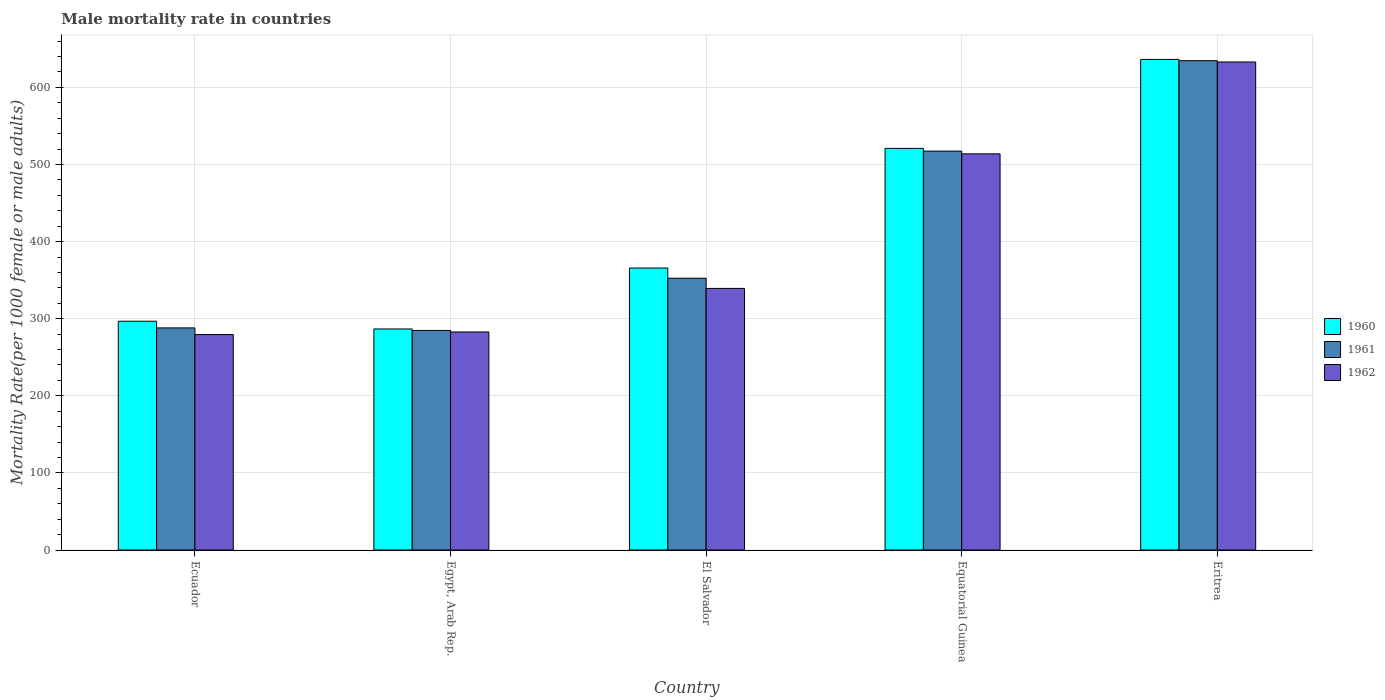How many different coloured bars are there?
Give a very brief answer. 3. How many groups of bars are there?
Keep it short and to the point. 5. Are the number of bars per tick equal to the number of legend labels?
Ensure brevity in your answer.  Yes. Are the number of bars on each tick of the X-axis equal?
Give a very brief answer. Yes. How many bars are there on the 1st tick from the right?
Provide a short and direct response. 3. What is the label of the 1st group of bars from the left?
Your answer should be very brief. Ecuador. What is the male mortality rate in 1961 in Egypt, Arab Rep.?
Make the answer very short. 284.74. Across all countries, what is the maximum male mortality rate in 1961?
Offer a very short reply. 634.63. Across all countries, what is the minimum male mortality rate in 1960?
Ensure brevity in your answer.  286.69. In which country was the male mortality rate in 1960 maximum?
Provide a short and direct response. Eritrea. In which country was the male mortality rate in 1962 minimum?
Ensure brevity in your answer.  Ecuador. What is the total male mortality rate in 1960 in the graph?
Keep it short and to the point. 2106.34. What is the difference between the male mortality rate in 1960 in Ecuador and that in Egypt, Arab Rep.?
Provide a short and direct response. 10.02. What is the difference between the male mortality rate in 1962 in Eritrea and the male mortality rate in 1961 in Ecuador?
Your answer should be very brief. 344.9. What is the average male mortality rate in 1961 per country?
Offer a very short reply. 415.46. What is the difference between the male mortality rate of/in 1960 and male mortality rate of/in 1961 in El Salvador?
Your response must be concise. 13.23. In how many countries, is the male mortality rate in 1960 greater than 320?
Make the answer very short. 3. What is the ratio of the male mortality rate in 1962 in Ecuador to that in Eritrea?
Your answer should be compact. 0.44. Is the male mortality rate in 1962 in Ecuador less than that in Eritrea?
Keep it short and to the point. Yes. What is the difference between the highest and the second highest male mortality rate in 1961?
Provide a short and direct response. -282.13. What is the difference between the highest and the lowest male mortality rate in 1962?
Offer a very short reply. 353.55. In how many countries, is the male mortality rate in 1962 greater than the average male mortality rate in 1962 taken over all countries?
Offer a very short reply. 2. What does the 3rd bar from the left in Egypt, Arab Rep. represents?
Offer a very short reply. 1962. Are the values on the major ticks of Y-axis written in scientific E-notation?
Offer a very short reply. No. Where does the legend appear in the graph?
Provide a succinct answer. Center right. What is the title of the graph?
Offer a terse response. Male mortality rate in countries. Does "2005" appear as one of the legend labels in the graph?
Your response must be concise. No. What is the label or title of the X-axis?
Provide a succinct answer. Country. What is the label or title of the Y-axis?
Ensure brevity in your answer.  Mortality Rate(per 1000 female or male adults). What is the Mortality Rate(per 1000 female or male adults) in 1960 in Ecuador?
Provide a succinct answer. 296.71. What is the Mortality Rate(per 1000 female or male adults) in 1961 in Ecuador?
Make the answer very short. 288.06. What is the Mortality Rate(per 1000 female or male adults) of 1962 in Ecuador?
Your answer should be very brief. 279.4. What is the Mortality Rate(per 1000 female or male adults) in 1960 in Egypt, Arab Rep.?
Give a very brief answer. 286.69. What is the Mortality Rate(per 1000 female or male adults) of 1961 in Egypt, Arab Rep.?
Keep it short and to the point. 284.74. What is the Mortality Rate(per 1000 female or male adults) of 1962 in Egypt, Arab Rep.?
Offer a very short reply. 282.8. What is the Mortality Rate(per 1000 female or male adults) in 1960 in El Salvador?
Your response must be concise. 365.73. What is the Mortality Rate(per 1000 female or male adults) in 1961 in El Salvador?
Your answer should be very brief. 352.5. What is the Mortality Rate(per 1000 female or male adults) in 1962 in El Salvador?
Your answer should be very brief. 339.27. What is the Mortality Rate(per 1000 female or male adults) of 1960 in Equatorial Guinea?
Offer a very short reply. 520.91. What is the Mortality Rate(per 1000 female or male adults) in 1961 in Equatorial Guinea?
Give a very brief answer. 517.37. What is the Mortality Rate(per 1000 female or male adults) of 1962 in Equatorial Guinea?
Your answer should be compact. 513.83. What is the Mortality Rate(per 1000 female or male adults) of 1960 in Eritrea?
Make the answer very short. 636.3. What is the Mortality Rate(per 1000 female or male adults) in 1961 in Eritrea?
Make the answer very short. 634.63. What is the Mortality Rate(per 1000 female or male adults) of 1962 in Eritrea?
Offer a very short reply. 632.96. Across all countries, what is the maximum Mortality Rate(per 1000 female or male adults) in 1960?
Your response must be concise. 636.3. Across all countries, what is the maximum Mortality Rate(per 1000 female or male adults) of 1961?
Your answer should be compact. 634.63. Across all countries, what is the maximum Mortality Rate(per 1000 female or male adults) in 1962?
Offer a terse response. 632.96. Across all countries, what is the minimum Mortality Rate(per 1000 female or male adults) in 1960?
Make the answer very short. 286.69. Across all countries, what is the minimum Mortality Rate(per 1000 female or male adults) in 1961?
Ensure brevity in your answer.  284.74. Across all countries, what is the minimum Mortality Rate(per 1000 female or male adults) in 1962?
Offer a terse response. 279.4. What is the total Mortality Rate(per 1000 female or male adults) in 1960 in the graph?
Provide a succinct answer. 2106.34. What is the total Mortality Rate(per 1000 female or male adults) in 1961 in the graph?
Make the answer very short. 2077.3. What is the total Mortality Rate(per 1000 female or male adults) in 1962 in the graph?
Ensure brevity in your answer.  2048.25. What is the difference between the Mortality Rate(per 1000 female or male adults) in 1960 in Ecuador and that in Egypt, Arab Rep.?
Offer a very short reply. 10.02. What is the difference between the Mortality Rate(per 1000 female or male adults) of 1961 in Ecuador and that in Egypt, Arab Rep.?
Ensure brevity in your answer.  3.32. What is the difference between the Mortality Rate(per 1000 female or male adults) in 1962 in Ecuador and that in Egypt, Arab Rep.?
Give a very brief answer. -3.39. What is the difference between the Mortality Rate(per 1000 female or male adults) of 1960 in Ecuador and that in El Salvador?
Your answer should be compact. -69.01. What is the difference between the Mortality Rate(per 1000 female or male adults) of 1961 in Ecuador and that in El Salvador?
Your answer should be compact. -64.44. What is the difference between the Mortality Rate(per 1000 female or male adults) in 1962 in Ecuador and that in El Salvador?
Provide a short and direct response. -59.86. What is the difference between the Mortality Rate(per 1000 female or male adults) in 1960 in Ecuador and that in Equatorial Guinea?
Make the answer very short. -224.2. What is the difference between the Mortality Rate(per 1000 female or male adults) of 1961 in Ecuador and that in Equatorial Guinea?
Ensure brevity in your answer.  -229.31. What is the difference between the Mortality Rate(per 1000 female or male adults) of 1962 in Ecuador and that in Equatorial Guinea?
Ensure brevity in your answer.  -234.42. What is the difference between the Mortality Rate(per 1000 female or male adults) of 1960 in Ecuador and that in Eritrea?
Your response must be concise. -339.58. What is the difference between the Mortality Rate(per 1000 female or male adults) in 1961 in Ecuador and that in Eritrea?
Offer a terse response. -346.57. What is the difference between the Mortality Rate(per 1000 female or male adults) of 1962 in Ecuador and that in Eritrea?
Provide a short and direct response. -353.55. What is the difference between the Mortality Rate(per 1000 female or male adults) in 1960 in Egypt, Arab Rep. and that in El Salvador?
Provide a short and direct response. -79.03. What is the difference between the Mortality Rate(per 1000 female or male adults) of 1961 in Egypt, Arab Rep. and that in El Salvador?
Your answer should be compact. -67.75. What is the difference between the Mortality Rate(per 1000 female or male adults) of 1962 in Egypt, Arab Rep. and that in El Salvador?
Your answer should be compact. -56.47. What is the difference between the Mortality Rate(per 1000 female or male adults) in 1960 in Egypt, Arab Rep. and that in Equatorial Guinea?
Your answer should be very brief. -234.22. What is the difference between the Mortality Rate(per 1000 female or male adults) in 1961 in Egypt, Arab Rep. and that in Equatorial Guinea?
Offer a terse response. -232.62. What is the difference between the Mortality Rate(per 1000 female or male adults) in 1962 in Egypt, Arab Rep. and that in Equatorial Guinea?
Provide a succinct answer. -231.03. What is the difference between the Mortality Rate(per 1000 female or male adults) of 1960 in Egypt, Arab Rep. and that in Eritrea?
Your answer should be compact. -349.61. What is the difference between the Mortality Rate(per 1000 female or male adults) in 1961 in Egypt, Arab Rep. and that in Eritrea?
Make the answer very short. -349.88. What is the difference between the Mortality Rate(per 1000 female or male adults) of 1962 in Egypt, Arab Rep. and that in Eritrea?
Keep it short and to the point. -350.16. What is the difference between the Mortality Rate(per 1000 female or male adults) in 1960 in El Salvador and that in Equatorial Guinea?
Your answer should be compact. -155.19. What is the difference between the Mortality Rate(per 1000 female or male adults) in 1961 in El Salvador and that in Equatorial Guinea?
Make the answer very short. -164.87. What is the difference between the Mortality Rate(per 1000 female or male adults) of 1962 in El Salvador and that in Equatorial Guinea?
Offer a very short reply. -174.56. What is the difference between the Mortality Rate(per 1000 female or male adults) of 1960 in El Salvador and that in Eritrea?
Offer a terse response. -270.57. What is the difference between the Mortality Rate(per 1000 female or male adults) in 1961 in El Salvador and that in Eritrea?
Ensure brevity in your answer.  -282.13. What is the difference between the Mortality Rate(per 1000 female or male adults) of 1962 in El Salvador and that in Eritrea?
Make the answer very short. -293.69. What is the difference between the Mortality Rate(per 1000 female or male adults) in 1960 in Equatorial Guinea and that in Eritrea?
Make the answer very short. -115.39. What is the difference between the Mortality Rate(per 1000 female or male adults) of 1961 in Equatorial Guinea and that in Eritrea?
Offer a terse response. -117.26. What is the difference between the Mortality Rate(per 1000 female or male adults) of 1962 in Equatorial Guinea and that in Eritrea?
Your answer should be compact. -119.13. What is the difference between the Mortality Rate(per 1000 female or male adults) of 1960 in Ecuador and the Mortality Rate(per 1000 female or male adults) of 1961 in Egypt, Arab Rep.?
Provide a short and direct response. 11.97. What is the difference between the Mortality Rate(per 1000 female or male adults) in 1960 in Ecuador and the Mortality Rate(per 1000 female or male adults) in 1962 in Egypt, Arab Rep.?
Your response must be concise. 13.92. What is the difference between the Mortality Rate(per 1000 female or male adults) of 1961 in Ecuador and the Mortality Rate(per 1000 female or male adults) of 1962 in Egypt, Arab Rep.?
Provide a short and direct response. 5.26. What is the difference between the Mortality Rate(per 1000 female or male adults) of 1960 in Ecuador and the Mortality Rate(per 1000 female or male adults) of 1961 in El Salvador?
Keep it short and to the point. -55.78. What is the difference between the Mortality Rate(per 1000 female or male adults) of 1960 in Ecuador and the Mortality Rate(per 1000 female or male adults) of 1962 in El Salvador?
Your answer should be very brief. -42.55. What is the difference between the Mortality Rate(per 1000 female or male adults) in 1961 in Ecuador and the Mortality Rate(per 1000 female or male adults) in 1962 in El Salvador?
Keep it short and to the point. -51.21. What is the difference between the Mortality Rate(per 1000 female or male adults) in 1960 in Ecuador and the Mortality Rate(per 1000 female or male adults) in 1961 in Equatorial Guinea?
Provide a succinct answer. -220.66. What is the difference between the Mortality Rate(per 1000 female or male adults) in 1960 in Ecuador and the Mortality Rate(per 1000 female or male adults) in 1962 in Equatorial Guinea?
Ensure brevity in your answer.  -217.11. What is the difference between the Mortality Rate(per 1000 female or male adults) of 1961 in Ecuador and the Mortality Rate(per 1000 female or male adults) of 1962 in Equatorial Guinea?
Make the answer very short. -225.77. What is the difference between the Mortality Rate(per 1000 female or male adults) of 1960 in Ecuador and the Mortality Rate(per 1000 female or male adults) of 1961 in Eritrea?
Offer a terse response. -337.91. What is the difference between the Mortality Rate(per 1000 female or male adults) in 1960 in Ecuador and the Mortality Rate(per 1000 female or male adults) in 1962 in Eritrea?
Offer a terse response. -336.24. What is the difference between the Mortality Rate(per 1000 female or male adults) of 1961 in Ecuador and the Mortality Rate(per 1000 female or male adults) of 1962 in Eritrea?
Give a very brief answer. -344.9. What is the difference between the Mortality Rate(per 1000 female or male adults) in 1960 in Egypt, Arab Rep. and the Mortality Rate(per 1000 female or male adults) in 1961 in El Salvador?
Give a very brief answer. -65.8. What is the difference between the Mortality Rate(per 1000 female or male adults) in 1960 in Egypt, Arab Rep. and the Mortality Rate(per 1000 female or male adults) in 1962 in El Salvador?
Provide a succinct answer. -52.57. What is the difference between the Mortality Rate(per 1000 female or male adults) of 1961 in Egypt, Arab Rep. and the Mortality Rate(per 1000 female or male adults) of 1962 in El Salvador?
Give a very brief answer. -54.52. What is the difference between the Mortality Rate(per 1000 female or male adults) of 1960 in Egypt, Arab Rep. and the Mortality Rate(per 1000 female or male adults) of 1961 in Equatorial Guinea?
Provide a short and direct response. -230.68. What is the difference between the Mortality Rate(per 1000 female or male adults) of 1960 in Egypt, Arab Rep. and the Mortality Rate(per 1000 female or male adults) of 1962 in Equatorial Guinea?
Offer a very short reply. -227.14. What is the difference between the Mortality Rate(per 1000 female or male adults) of 1961 in Egypt, Arab Rep. and the Mortality Rate(per 1000 female or male adults) of 1962 in Equatorial Guinea?
Provide a short and direct response. -229.08. What is the difference between the Mortality Rate(per 1000 female or male adults) in 1960 in Egypt, Arab Rep. and the Mortality Rate(per 1000 female or male adults) in 1961 in Eritrea?
Your answer should be compact. -347.94. What is the difference between the Mortality Rate(per 1000 female or male adults) in 1960 in Egypt, Arab Rep. and the Mortality Rate(per 1000 female or male adults) in 1962 in Eritrea?
Provide a succinct answer. -346.26. What is the difference between the Mortality Rate(per 1000 female or male adults) in 1961 in Egypt, Arab Rep. and the Mortality Rate(per 1000 female or male adults) in 1962 in Eritrea?
Provide a short and direct response. -348.21. What is the difference between the Mortality Rate(per 1000 female or male adults) in 1960 in El Salvador and the Mortality Rate(per 1000 female or male adults) in 1961 in Equatorial Guinea?
Your response must be concise. -151.64. What is the difference between the Mortality Rate(per 1000 female or male adults) in 1960 in El Salvador and the Mortality Rate(per 1000 female or male adults) in 1962 in Equatorial Guinea?
Offer a terse response. -148.1. What is the difference between the Mortality Rate(per 1000 female or male adults) of 1961 in El Salvador and the Mortality Rate(per 1000 female or male adults) of 1962 in Equatorial Guinea?
Your response must be concise. -161.33. What is the difference between the Mortality Rate(per 1000 female or male adults) of 1960 in El Salvador and the Mortality Rate(per 1000 female or male adults) of 1961 in Eritrea?
Your response must be concise. -268.9. What is the difference between the Mortality Rate(per 1000 female or male adults) in 1960 in El Salvador and the Mortality Rate(per 1000 female or male adults) in 1962 in Eritrea?
Keep it short and to the point. -267.23. What is the difference between the Mortality Rate(per 1000 female or male adults) of 1961 in El Salvador and the Mortality Rate(per 1000 female or male adults) of 1962 in Eritrea?
Offer a very short reply. -280.46. What is the difference between the Mortality Rate(per 1000 female or male adults) in 1960 in Equatorial Guinea and the Mortality Rate(per 1000 female or male adults) in 1961 in Eritrea?
Provide a short and direct response. -113.72. What is the difference between the Mortality Rate(per 1000 female or male adults) in 1960 in Equatorial Guinea and the Mortality Rate(per 1000 female or male adults) in 1962 in Eritrea?
Your answer should be very brief. -112.05. What is the difference between the Mortality Rate(per 1000 female or male adults) in 1961 in Equatorial Guinea and the Mortality Rate(per 1000 female or male adults) in 1962 in Eritrea?
Provide a short and direct response. -115.59. What is the average Mortality Rate(per 1000 female or male adults) of 1960 per country?
Make the answer very short. 421.27. What is the average Mortality Rate(per 1000 female or male adults) in 1961 per country?
Your response must be concise. 415.46. What is the average Mortality Rate(per 1000 female or male adults) in 1962 per country?
Offer a very short reply. 409.65. What is the difference between the Mortality Rate(per 1000 female or male adults) in 1960 and Mortality Rate(per 1000 female or male adults) in 1961 in Ecuador?
Make the answer very short. 8.65. What is the difference between the Mortality Rate(per 1000 female or male adults) of 1960 and Mortality Rate(per 1000 female or male adults) of 1962 in Ecuador?
Give a very brief answer. 17.31. What is the difference between the Mortality Rate(per 1000 female or male adults) in 1961 and Mortality Rate(per 1000 female or male adults) in 1962 in Ecuador?
Offer a terse response. 8.65. What is the difference between the Mortality Rate(per 1000 female or male adults) of 1960 and Mortality Rate(per 1000 female or male adults) of 1961 in Egypt, Arab Rep.?
Offer a very short reply. 1.95. What is the difference between the Mortality Rate(per 1000 female or male adults) of 1960 and Mortality Rate(per 1000 female or male adults) of 1962 in Egypt, Arab Rep.?
Your answer should be compact. 3.9. What is the difference between the Mortality Rate(per 1000 female or male adults) of 1961 and Mortality Rate(per 1000 female or male adults) of 1962 in Egypt, Arab Rep.?
Keep it short and to the point. 1.95. What is the difference between the Mortality Rate(per 1000 female or male adults) in 1960 and Mortality Rate(per 1000 female or male adults) in 1961 in El Salvador?
Ensure brevity in your answer.  13.23. What is the difference between the Mortality Rate(per 1000 female or male adults) of 1960 and Mortality Rate(per 1000 female or male adults) of 1962 in El Salvador?
Provide a succinct answer. 26.46. What is the difference between the Mortality Rate(per 1000 female or male adults) in 1961 and Mortality Rate(per 1000 female or male adults) in 1962 in El Salvador?
Keep it short and to the point. 13.23. What is the difference between the Mortality Rate(per 1000 female or male adults) of 1960 and Mortality Rate(per 1000 female or male adults) of 1961 in Equatorial Guinea?
Offer a terse response. 3.54. What is the difference between the Mortality Rate(per 1000 female or male adults) in 1960 and Mortality Rate(per 1000 female or male adults) in 1962 in Equatorial Guinea?
Ensure brevity in your answer.  7.08. What is the difference between the Mortality Rate(per 1000 female or male adults) of 1961 and Mortality Rate(per 1000 female or male adults) of 1962 in Equatorial Guinea?
Keep it short and to the point. 3.54. What is the difference between the Mortality Rate(per 1000 female or male adults) of 1960 and Mortality Rate(per 1000 female or male adults) of 1961 in Eritrea?
Offer a very short reply. 1.67. What is the difference between the Mortality Rate(per 1000 female or male adults) of 1960 and Mortality Rate(per 1000 female or male adults) of 1962 in Eritrea?
Give a very brief answer. 3.34. What is the difference between the Mortality Rate(per 1000 female or male adults) of 1961 and Mortality Rate(per 1000 female or male adults) of 1962 in Eritrea?
Offer a very short reply. 1.67. What is the ratio of the Mortality Rate(per 1000 female or male adults) in 1960 in Ecuador to that in Egypt, Arab Rep.?
Offer a very short reply. 1.03. What is the ratio of the Mortality Rate(per 1000 female or male adults) of 1961 in Ecuador to that in Egypt, Arab Rep.?
Provide a succinct answer. 1.01. What is the ratio of the Mortality Rate(per 1000 female or male adults) of 1960 in Ecuador to that in El Salvador?
Your answer should be compact. 0.81. What is the ratio of the Mortality Rate(per 1000 female or male adults) of 1961 in Ecuador to that in El Salvador?
Keep it short and to the point. 0.82. What is the ratio of the Mortality Rate(per 1000 female or male adults) of 1962 in Ecuador to that in El Salvador?
Provide a succinct answer. 0.82. What is the ratio of the Mortality Rate(per 1000 female or male adults) in 1960 in Ecuador to that in Equatorial Guinea?
Offer a terse response. 0.57. What is the ratio of the Mortality Rate(per 1000 female or male adults) of 1961 in Ecuador to that in Equatorial Guinea?
Make the answer very short. 0.56. What is the ratio of the Mortality Rate(per 1000 female or male adults) of 1962 in Ecuador to that in Equatorial Guinea?
Offer a very short reply. 0.54. What is the ratio of the Mortality Rate(per 1000 female or male adults) of 1960 in Ecuador to that in Eritrea?
Your response must be concise. 0.47. What is the ratio of the Mortality Rate(per 1000 female or male adults) of 1961 in Ecuador to that in Eritrea?
Provide a succinct answer. 0.45. What is the ratio of the Mortality Rate(per 1000 female or male adults) of 1962 in Ecuador to that in Eritrea?
Keep it short and to the point. 0.44. What is the ratio of the Mortality Rate(per 1000 female or male adults) in 1960 in Egypt, Arab Rep. to that in El Salvador?
Offer a terse response. 0.78. What is the ratio of the Mortality Rate(per 1000 female or male adults) in 1961 in Egypt, Arab Rep. to that in El Salvador?
Make the answer very short. 0.81. What is the ratio of the Mortality Rate(per 1000 female or male adults) in 1962 in Egypt, Arab Rep. to that in El Salvador?
Make the answer very short. 0.83. What is the ratio of the Mortality Rate(per 1000 female or male adults) in 1960 in Egypt, Arab Rep. to that in Equatorial Guinea?
Offer a very short reply. 0.55. What is the ratio of the Mortality Rate(per 1000 female or male adults) in 1961 in Egypt, Arab Rep. to that in Equatorial Guinea?
Your answer should be very brief. 0.55. What is the ratio of the Mortality Rate(per 1000 female or male adults) of 1962 in Egypt, Arab Rep. to that in Equatorial Guinea?
Offer a very short reply. 0.55. What is the ratio of the Mortality Rate(per 1000 female or male adults) of 1960 in Egypt, Arab Rep. to that in Eritrea?
Your response must be concise. 0.45. What is the ratio of the Mortality Rate(per 1000 female or male adults) of 1961 in Egypt, Arab Rep. to that in Eritrea?
Make the answer very short. 0.45. What is the ratio of the Mortality Rate(per 1000 female or male adults) of 1962 in Egypt, Arab Rep. to that in Eritrea?
Offer a very short reply. 0.45. What is the ratio of the Mortality Rate(per 1000 female or male adults) in 1960 in El Salvador to that in Equatorial Guinea?
Keep it short and to the point. 0.7. What is the ratio of the Mortality Rate(per 1000 female or male adults) in 1961 in El Salvador to that in Equatorial Guinea?
Ensure brevity in your answer.  0.68. What is the ratio of the Mortality Rate(per 1000 female or male adults) of 1962 in El Salvador to that in Equatorial Guinea?
Offer a very short reply. 0.66. What is the ratio of the Mortality Rate(per 1000 female or male adults) in 1960 in El Salvador to that in Eritrea?
Provide a succinct answer. 0.57. What is the ratio of the Mortality Rate(per 1000 female or male adults) of 1961 in El Salvador to that in Eritrea?
Your answer should be very brief. 0.56. What is the ratio of the Mortality Rate(per 1000 female or male adults) in 1962 in El Salvador to that in Eritrea?
Ensure brevity in your answer.  0.54. What is the ratio of the Mortality Rate(per 1000 female or male adults) in 1960 in Equatorial Guinea to that in Eritrea?
Provide a succinct answer. 0.82. What is the ratio of the Mortality Rate(per 1000 female or male adults) of 1961 in Equatorial Guinea to that in Eritrea?
Ensure brevity in your answer.  0.82. What is the ratio of the Mortality Rate(per 1000 female or male adults) of 1962 in Equatorial Guinea to that in Eritrea?
Keep it short and to the point. 0.81. What is the difference between the highest and the second highest Mortality Rate(per 1000 female or male adults) of 1960?
Your answer should be very brief. 115.39. What is the difference between the highest and the second highest Mortality Rate(per 1000 female or male adults) of 1961?
Keep it short and to the point. 117.26. What is the difference between the highest and the second highest Mortality Rate(per 1000 female or male adults) in 1962?
Offer a very short reply. 119.13. What is the difference between the highest and the lowest Mortality Rate(per 1000 female or male adults) of 1960?
Your answer should be very brief. 349.61. What is the difference between the highest and the lowest Mortality Rate(per 1000 female or male adults) of 1961?
Keep it short and to the point. 349.88. What is the difference between the highest and the lowest Mortality Rate(per 1000 female or male adults) of 1962?
Your answer should be very brief. 353.55. 